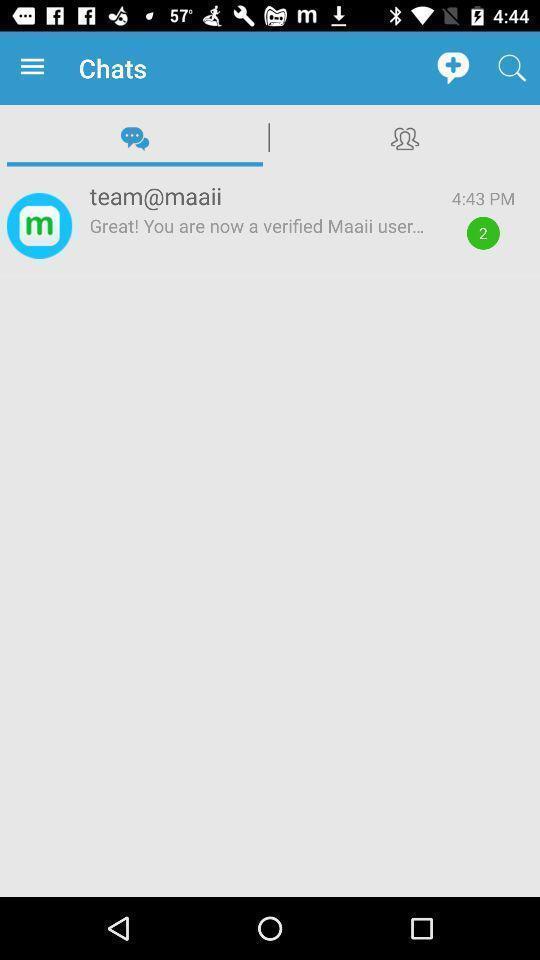Tell me what you see in this picture. Window displaying a messaging app. 